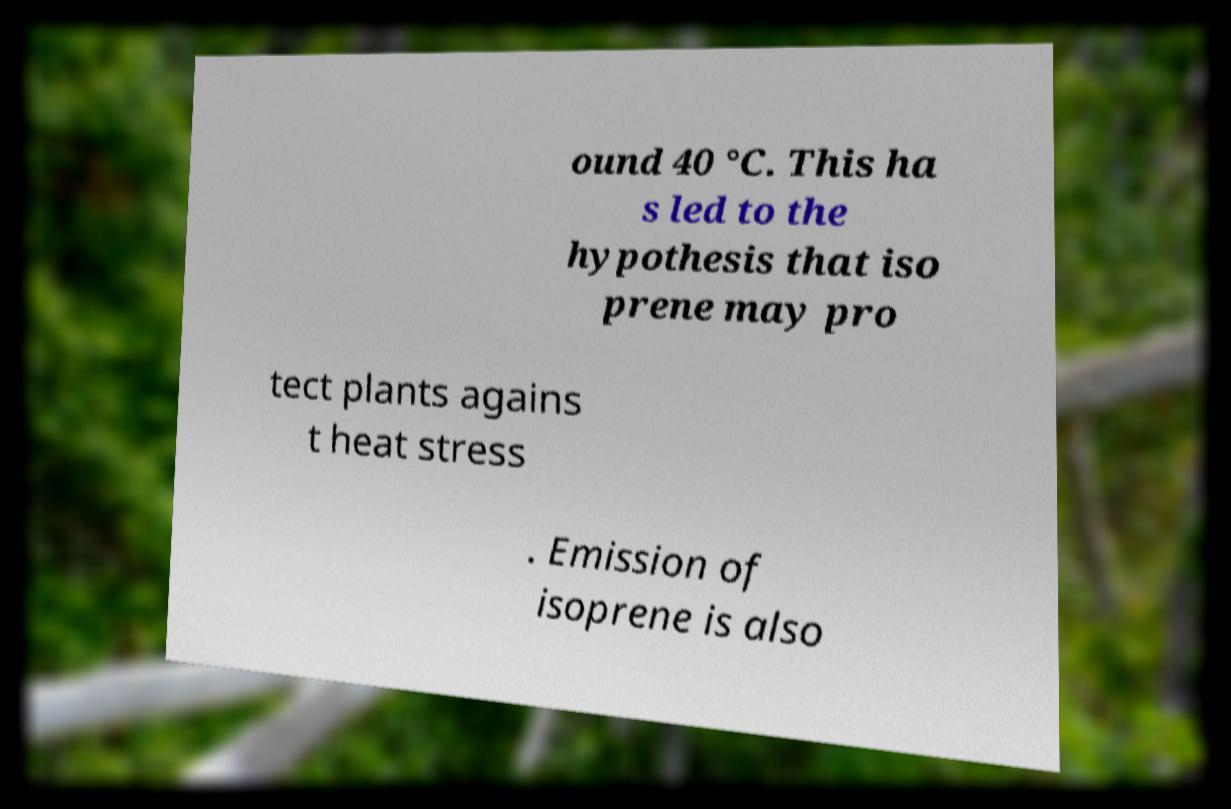For documentation purposes, I need the text within this image transcribed. Could you provide that? ound 40 °C. This ha s led to the hypothesis that iso prene may pro tect plants agains t heat stress . Emission of isoprene is also 